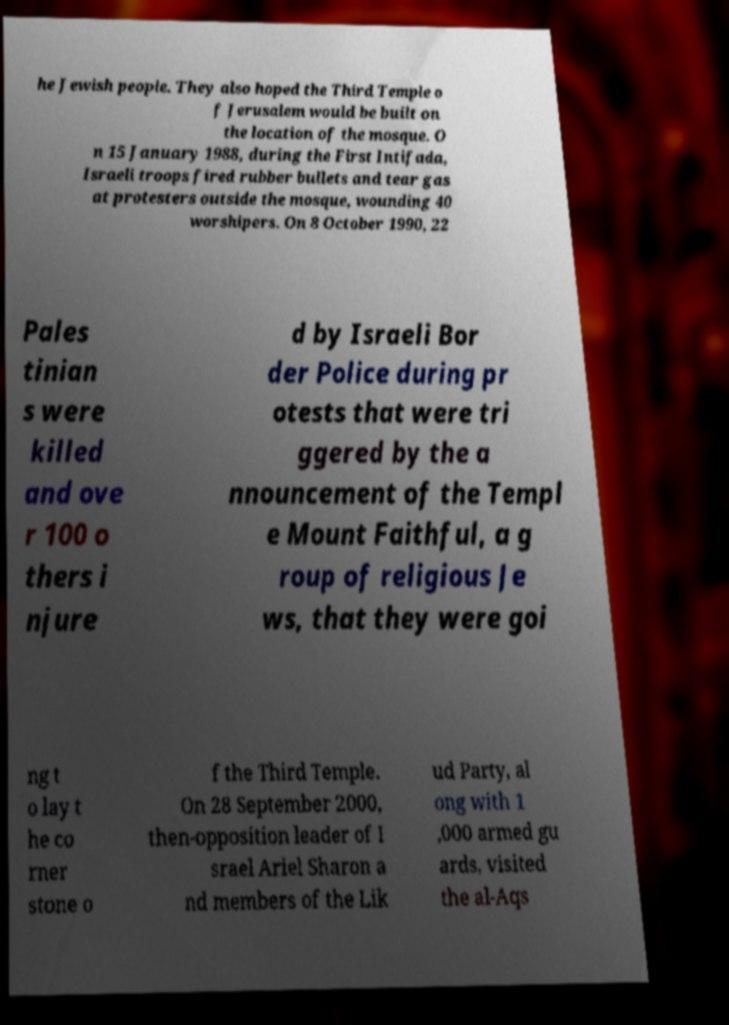There's text embedded in this image that I need extracted. Can you transcribe it verbatim? he Jewish people. They also hoped the Third Temple o f Jerusalem would be built on the location of the mosque. O n 15 January 1988, during the First Intifada, Israeli troops fired rubber bullets and tear gas at protesters outside the mosque, wounding 40 worshipers. On 8 October 1990, 22 Pales tinian s were killed and ove r 100 o thers i njure d by Israeli Bor der Police during pr otests that were tri ggered by the a nnouncement of the Templ e Mount Faithful, a g roup of religious Je ws, that they were goi ng t o lay t he co rner stone o f the Third Temple. On 28 September 2000, then-opposition leader of I srael Ariel Sharon a nd members of the Lik ud Party, al ong with 1 ,000 armed gu ards, visited the al-Aqs 